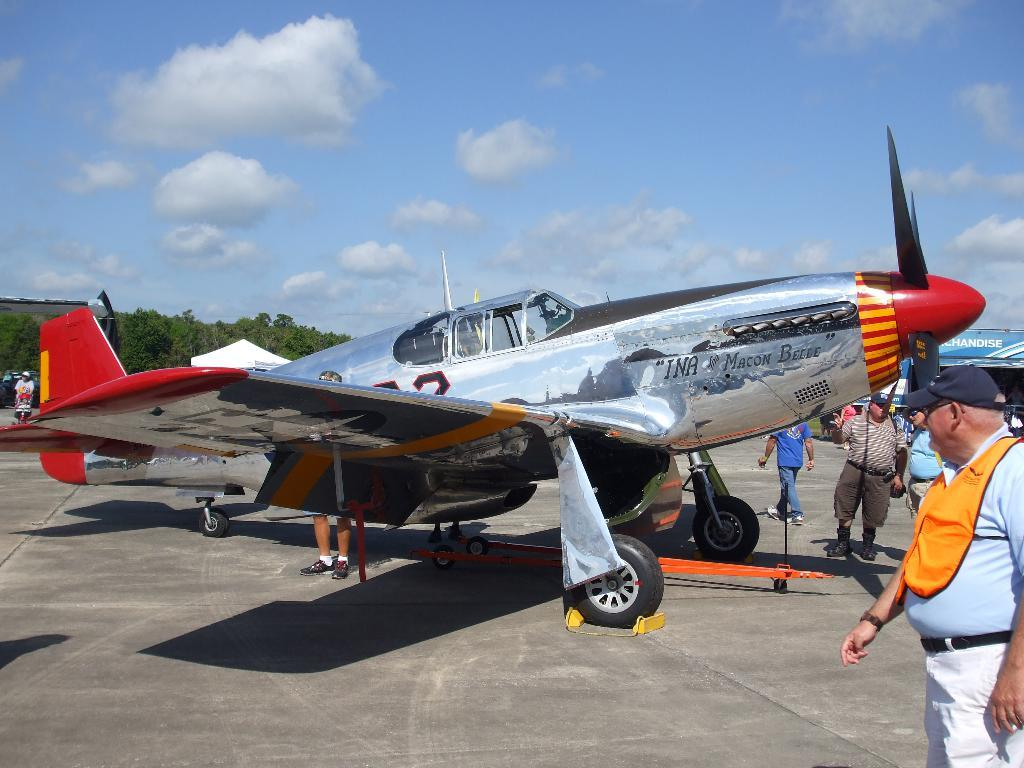What is located on the platform in the image? There is an aircraft on the platform in the image. Can you describe the people visible in the image? There are people visible in the image, but their specific actions or roles cannot be determined from the provided facts. What type of structure is present in the image? There is a shed in the image. What can be seen in the background of the image? The sky in the background appears to be cloudy. Reasoning: Let' Let's think step by step in order to produce the conversation. We start by identifying the main subject on the platform, which is the aircraft. Then, we mention the presence of people in the image, although we cannot determine their specific actions or roles. Next, we identify the shed as another structure present in the image. Finally, we describe the sky in the background, noting that it appears to be cloudy. Absurd Question/Answer: What type of wristwatch is the aircraft wearing in the image? There is no wristwatch or any indication of a wristwatch in the image, as the subject is an aircraft. 